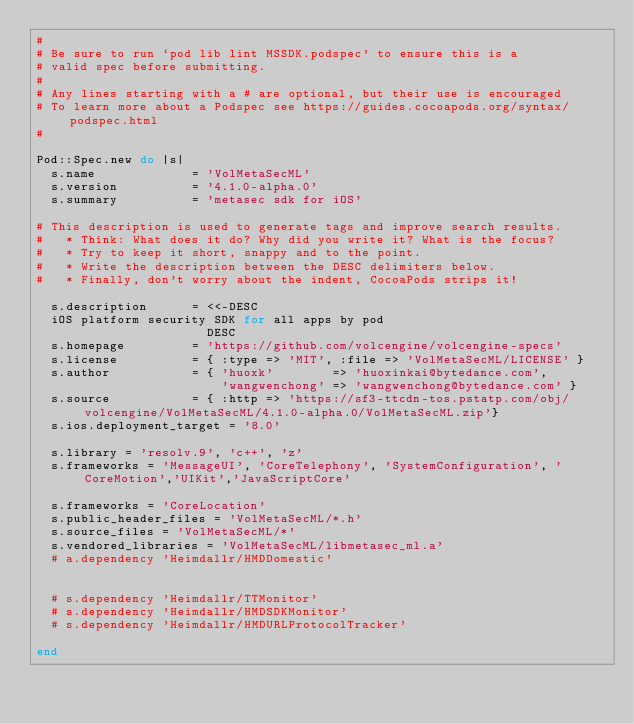Convert code to text. <code><loc_0><loc_0><loc_500><loc_500><_Ruby_>#
# Be sure to run `pod lib lint MSSDK.podspec' to ensure this is a
# valid spec before submitting.
#
# Any lines starting with a # are optional, but their use is encouraged
# To learn more about a Podspec see https://guides.cocoapods.org/syntax/podspec.html
#

Pod::Spec.new do |s|
  s.name             = 'VolMetaSecML'
  s.version          = '4.1.0-alpha.0'
  s.summary          = 'metasec sdk for iOS'

# This description is used to generate tags and improve search results.
#   * Think: What does it do? Why did you write it? What is the focus?
#   * Try to keep it short, snappy and to the point.
#   * Write the description between the DESC delimiters below.
#   * Finally, don't worry about the indent, CocoaPods strips it!

  s.description      = <<-DESC
  iOS platform security SDK for all apps by pod
                       DESC
  s.homepage         = 'https://github.com/volcengine/volcengine-specs'
  s.license          = { :type => 'MIT', :file => 'VolMetaSecML/LICENSE' }
  s.author           = { 'huoxk'        => 'huoxinkai@bytedance.com',
                         'wangwenchong' => 'wangwenchong@bytedance.com' }
  s.source           = { :http => 'https://sf3-ttcdn-tos.pstatp.com/obj/volcengine/VolMetaSecML/4.1.0-alpha.0/VolMetaSecML.zip'}
  s.ios.deployment_target = '8.0'

  s.library = 'resolv.9', 'c++', 'z'
  s.frameworks = 'MessageUI', 'CoreTelephony', 'SystemConfiguration', 'CoreMotion','UIKit','JavaScriptCore'

  s.frameworks = 'CoreLocation'
  s.public_header_files = 'VolMetaSecML/*.h'
  s.source_files = 'VolMetaSecML/*'
  s.vendored_libraries = 'VolMetaSecML/libmetasec_ml.a'
  # a.dependency 'Heimdallr/HMDDomestic'
  
  
  # s.dependency 'Heimdallr/TTMonitor'
  # s.dependency 'Heimdallr/HMDSDKMonitor'
  # s.dependency 'Heimdallr/HMDURLProtocolTracker'
  
end
</code> 